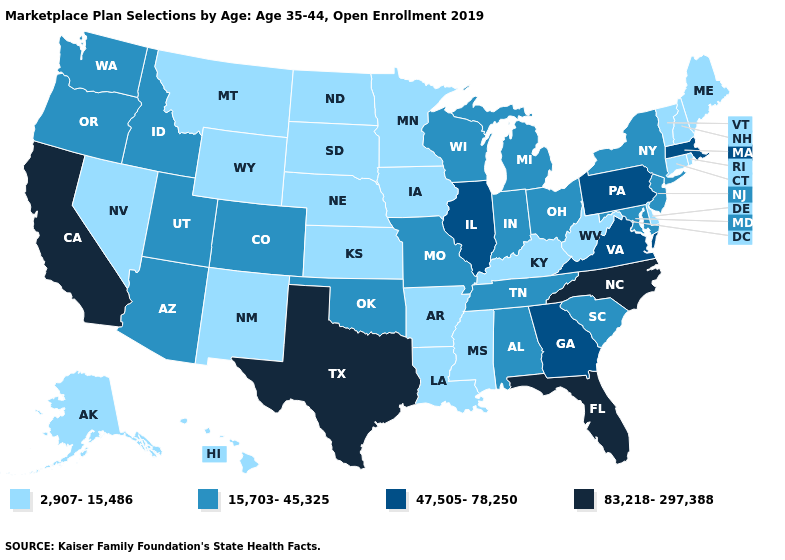Name the states that have a value in the range 83,218-297,388?
Concise answer only. California, Florida, North Carolina, Texas. Among the states that border Nebraska , which have the lowest value?
Short answer required. Iowa, Kansas, South Dakota, Wyoming. Name the states that have a value in the range 47,505-78,250?
Keep it brief. Georgia, Illinois, Massachusetts, Pennsylvania, Virginia. What is the value of Mississippi?
Short answer required. 2,907-15,486. Does the map have missing data?
Write a very short answer. No. What is the lowest value in the South?
Give a very brief answer. 2,907-15,486. Name the states that have a value in the range 83,218-297,388?
Quick response, please. California, Florida, North Carolina, Texas. Among the states that border Wisconsin , does Illinois have the lowest value?
Answer briefly. No. Which states have the lowest value in the USA?
Short answer required. Alaska, Arkansas, Connecticut, Delaware, Hawaii, Iowa, Kansas, Kentucky, Louisiana, Maine, Minnesota, Mississippi, Montana, Nebraska, Nevada, New Hampshire, New Mexico, North Dakota, Rhode Island, South Dakota, Vermont, West Virginia, Wyoming. Does Idaho have the same value as Maryland?
Be succinct. Yes. Which states hav the highest value in the MidWest?
Write a very short answer. Illinois. Among the states that border Idaho , which have the lowest value?
Be succinct. Montana, Nevada, Wyoming. Which states have the highest value in the USA?
Keep it brief. California, Florida, North Carolina, Texas. Does the map have missing data?
Answer briefly. No. 